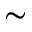<formula> <loc_0><loc_0><loc_500><loc_500>\sim</formula> 